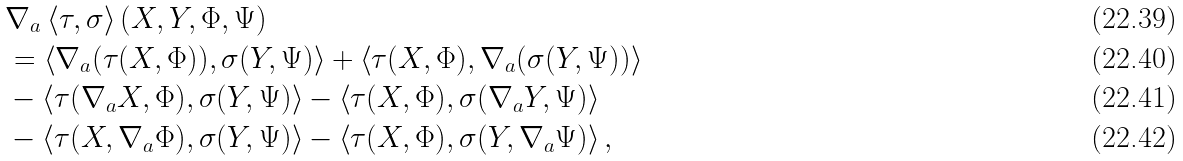<formula> <loc_0><loc_0><loc_500><loc_500>& \nabla _ { a } \left \langle \tau , \sigma \right \rangle ( X , Y , \Phi , \Psi ) \\ & = \left \langle \nabla _ { a } ( \tau ( X , \Phi ) ) , \sigma ( Y , \Psi ) \right \rangle + \left \langle \tau ( X , \Phi ) , \nabla _ { a } ( \sigma ( Y , \Psi ) ) \right \rangle \\ & - \left \langle \tau ( \nabla _ { a } X , \Phi ) , \sigma ( Y , \Psi ) \right \rangle - \left \langle \tau ( X , \Phi ) , \sigma ( \nabla _ { a } Y , \Psi ) \right \rangle \\ & - \left \langle \tau ( X , \nabla _ { a } \Phi ) , \sigma ( Y , \Psi ) \right \rangle - \left \langle \tau ( X , \Phi ) , \sigma ( Y , \nabla _ { a } \Psi ) \right \rangle ,</formula> 